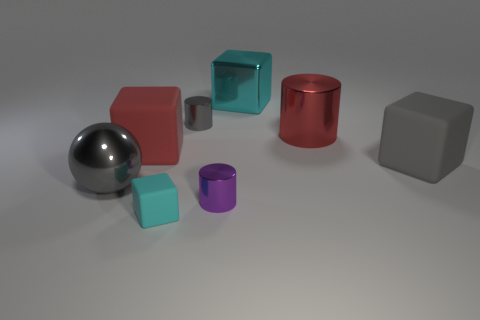Add 1 gray metal objects. How many objects exist? 9 Subtract all purple metallic cylinders. How many cylinders are left? 2 Subtract all yellow balls. How many cyan cubes are left? 2 Subtract 1 cylinders. How many cylinders are left? 2 Subtract all gray blocks. How many blocks are left? 3 Add 1 big matte blocks. How many big matte blocks are left? 3 Add 3 big red shiny cylinders. How many big red shiny cylinders exist? 4 Subtract 2 cyan blocks. How many objects are left? 6 Subtract all cylinders. How many objects are left? 5 Subtract all brown cylinders. Subtract all green balls. How many cylinders are left? 3 